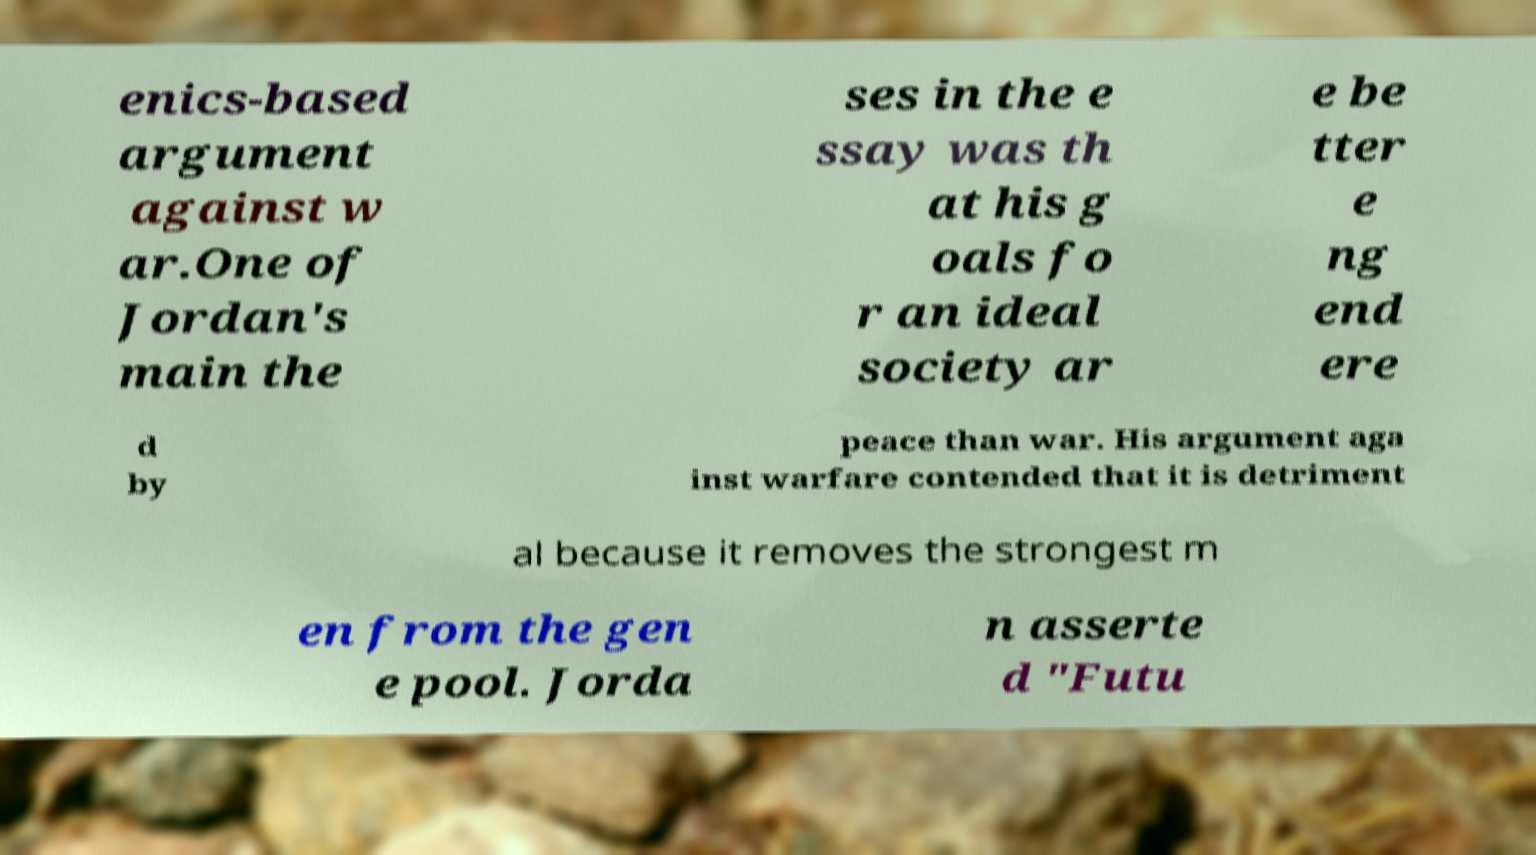Please identify and transcribe the text found in this image. enics-based argument against w ar.One of Jordan's main the ses in the e ssay was th at his g oals fo r an ideal society ar e be tter e ng end ere d by peace than war. His argument aga inst warfare contended that it is detriment al because it removes the strongest m en from the gen e pool. Jorda n asserte d "Futu 